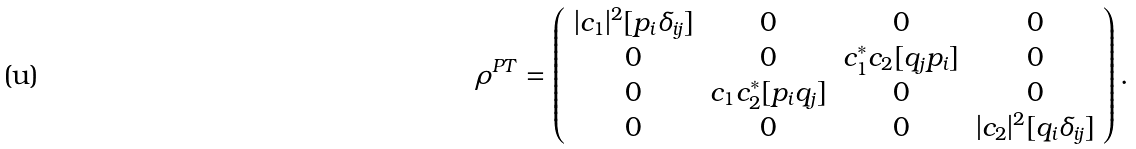<formula> <loc_0><loc_0><loc_500><loc_500>\rho ^ { P T } = \left ( \begin{array} { c c c c } | c _ { 1 } | ^ { 2 } [ p _ { i } \delta _ { i j } ] & 0 & 0 & 0 \\ 0 & 0 & c _ { 1 } ^ { * } c _ { 2 } [ q _ { j } p _ { i } ] & 0 \\ 0 & c _ { 1 } c _ { 2 } ^ { * } [ p _ { i } q _ { j } ] & 0 & 0 \\ 0 & 0 & 0 & | c _ { 2 } | ^ { 2 } [ q _ { i } \delta _ { i j } ] \end{array} \right ) .</formula> 